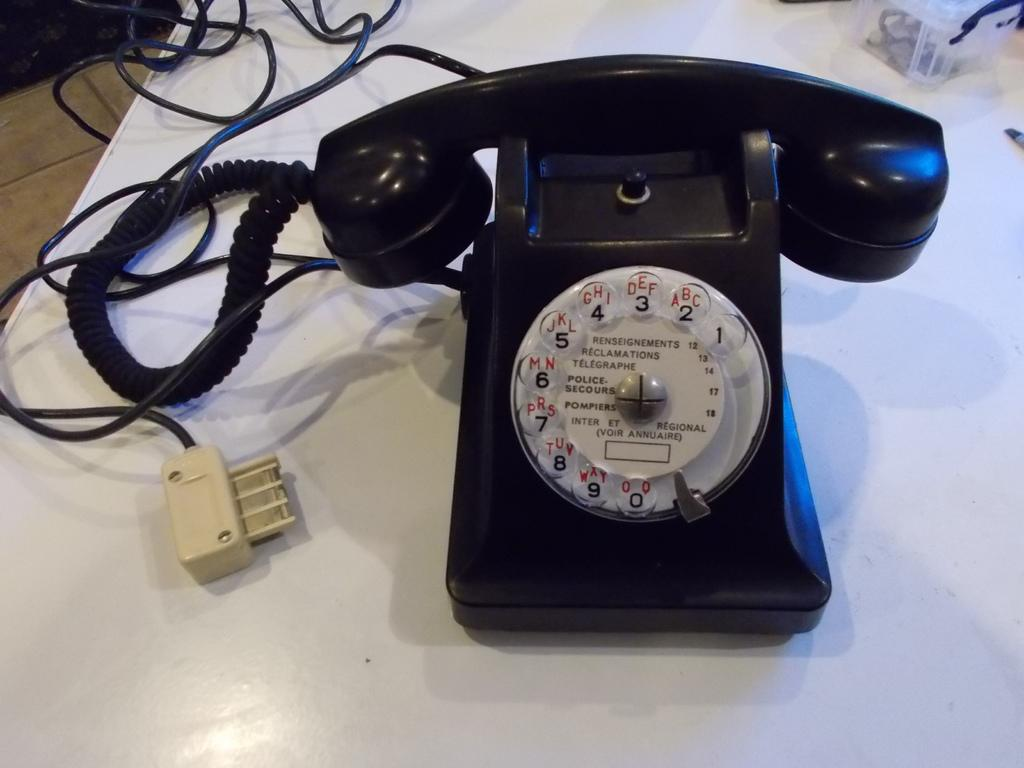What object related to communication is on the table in the image? There is a telephone on the table. What other object can be seen on the table? There is a box on the table. What else is present on the table that might be related to the objects mentioned? There are cables on the table. Can you describe the unspecified "things" on the table? Unfortunately, the facts provided do not give any details about the "things" on the table. How many pigs are visible on the table in the image? There are no pigs present in the image. What type of feet can be seen supporting the telephone on the table? The facts provided do not mention any feet supporting the telephone, and the image does not show any feet. 